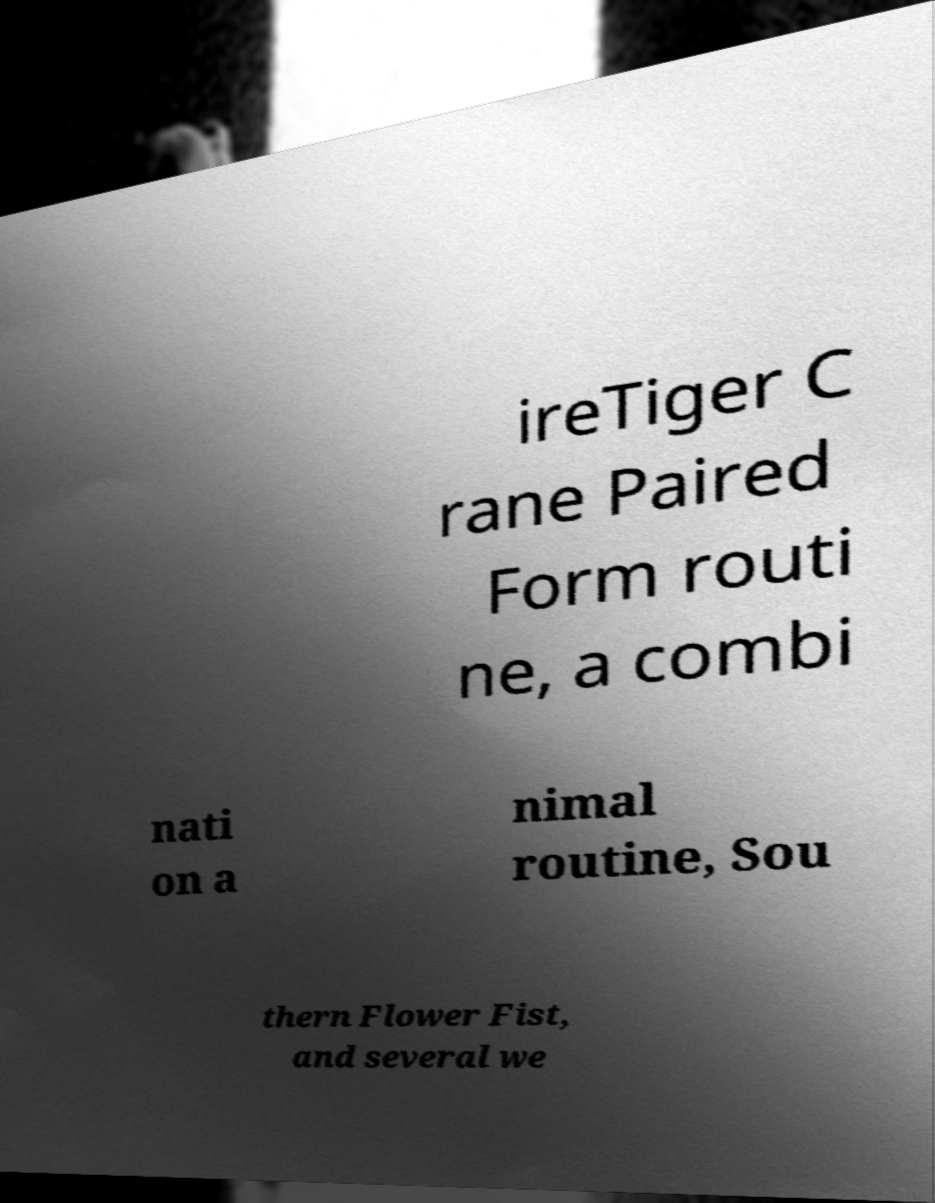Could you extract and type out the text from this image? ireTiger C rane Paired Form routi ne, a combi nati on a nimal routine, Sou thern Flower Fist, and several we 